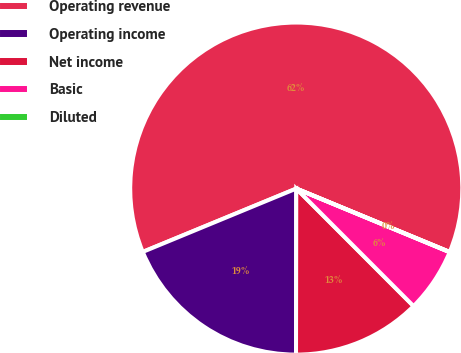<chart> <loc_0><loc_0><loc_500><loc_500><pie_chart><fcel>Operating revenue<fcel>Operating income<fcel>Net income<fcel>Basic<fcel>Diluted<nl><fcel>62.46%<fcel>18.75%<fcel>12.51%<fcel>6.26%<fcel>0.02%<nl></chart> 